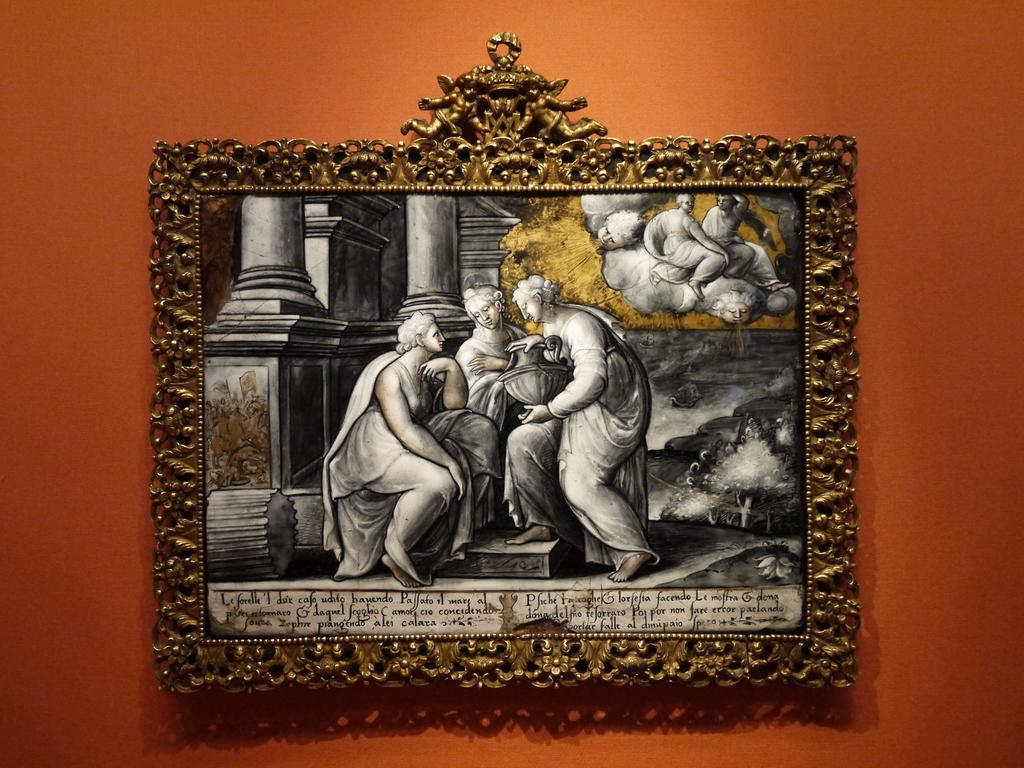What is the main subject in the center of the image? There is a frame in the center of the image. What is the color of the wall that the frame is attached to? The wall is plain and orange in color. What can be seen inside the frame? There are persons visible in the frame. What is written or displayed at the bottom of the frame? There is text at the bottom of the frame. Can you tell me how many monkeys are sitting on the camp in the image? There is no camp or monkeys present in the image. What type of creature is shown interacting with the persons in the frame? There is no creature shown interacting with the persons in the frame; only the persons and text are present. 